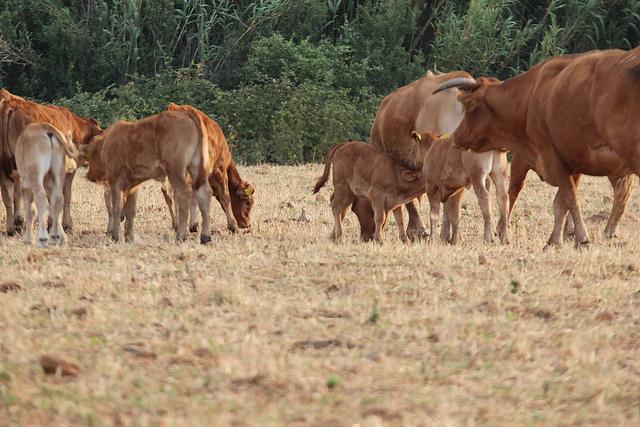How many cows are in the photo?
Give a very brief answer. 8. 